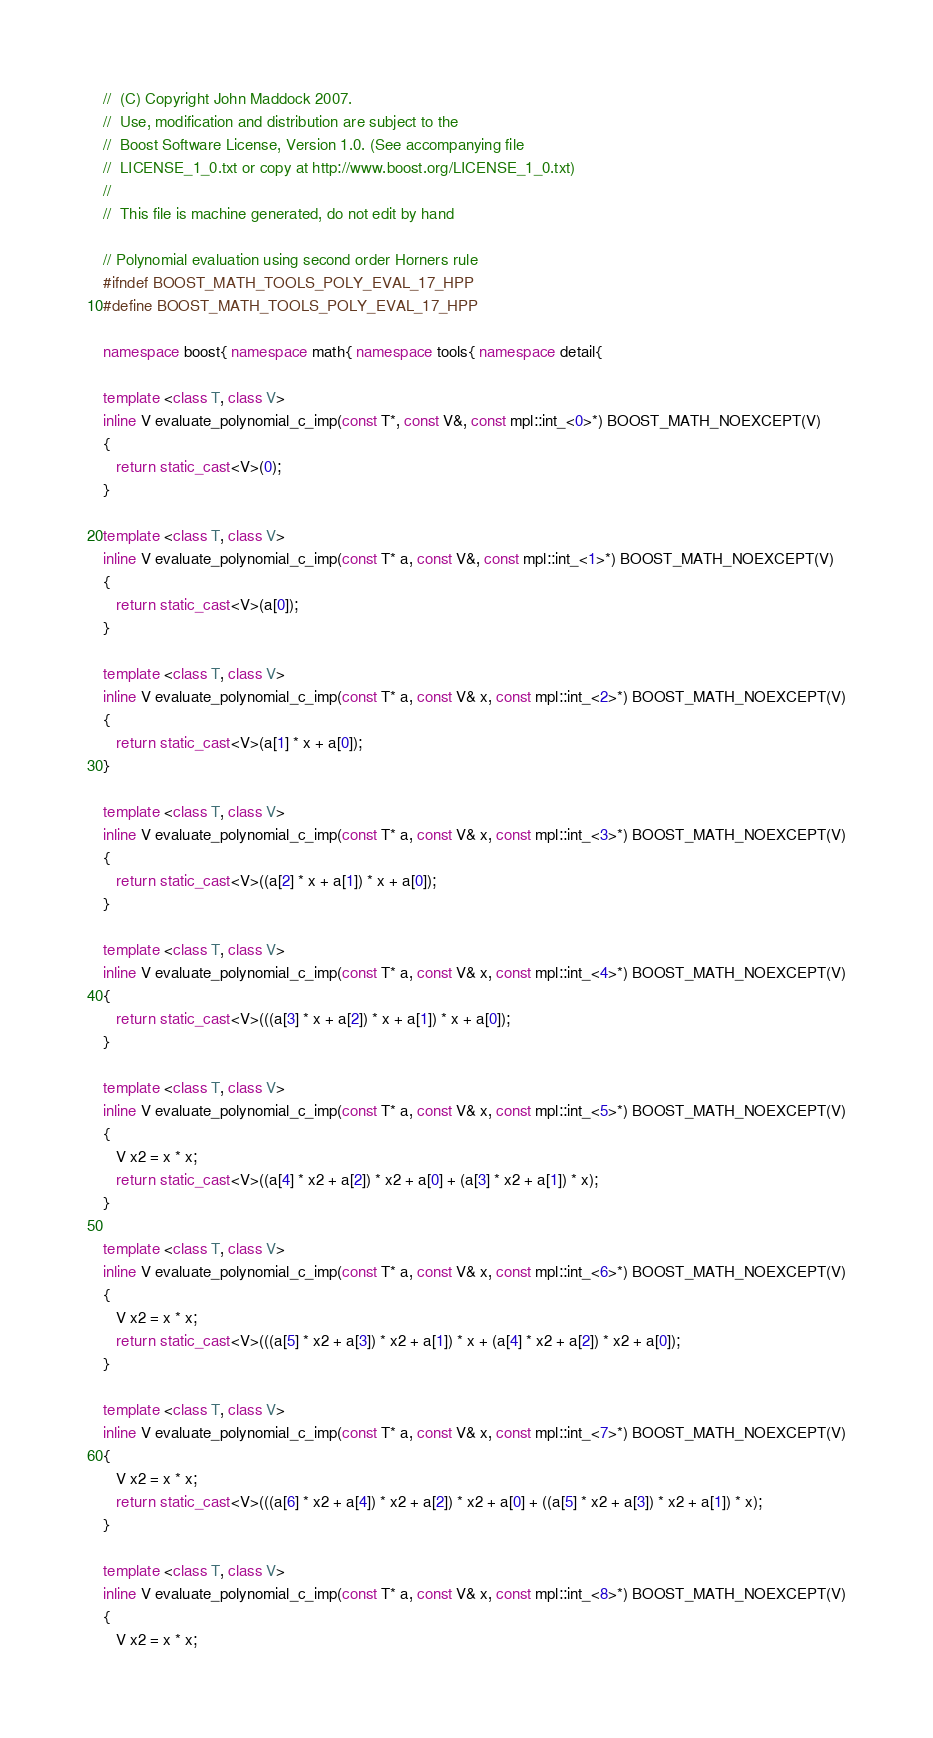<code> <loc_0><loc_0><loc_500><loc_500><_C++_>//  (C) Copyright John Maddock 2007.
//  Use, modification and distribution are subject to the
//  Boost Software License, Version 1.0. (See accompanying file
//  LICENSE_1_0.txt or copy at http://www.boost.org/LICENSE_1_0.txt)
//
//  This file is machine generated, do not edit by hand

// Polynomial evaluation using second order Horners rule
#ifndef BOOST_MATH_TOOLS_POLY_EVAL_17_HPP
#define BOOST_MATH_TOOLS_POLY_EVAL_17_HPP

namespace boost{ namespace math{ namespace tools{ namespace detail{

template <class T, class V>
inline V evaluate_polynomial_c_imp(const T*, const V&, const mpl::int_<0>*) BOOST_MATH_NOEXCEPT(V)
{
   return static_cast<V>(0);
}

template <class T, class V>
inline V evaluate_polynomial_c_imp(const T* a, const V&, const mpl::int_<1>*) BOOST_MATH_NOEXCEPT(V)
{
   return static_cast<V>(a[0]);
}

template <class T, class V>
inline V evaluate_polynomial_c_imp(const T* a, const V& x, const mpl::int_<2>*) BOOST_MATH_NOEXCEPT(V)
{
   return static_cast<V>(a[1] * x + a[0]);
}

template <class T, class V>
inline V evaluate_polynomial_c_imp(const T* a, const V& x, const mpl::int_<3>*) BOOST_MATH_NOEXCEPT(V)
{
   return static_cast<V>((a[2] * x + a[1]) * x + a[0]);
}

template <class T, class V>
inline V evaluate_polynomial_c_imp(const T* a, const V& x, const mpl::int_<4>*) BOOST_MATH_NOEXCEPT(V)
{
   return static_cast<V>(((a[3] * x + a[2]) * x + a[1]) * x + a[0]);
}

template <class T, class V>
inline V evaluate_polynomial_c_imp(const T* a, const V& x, const mpl::int_<5>*) BOOST_MATH_NOEXCEPT(V)
{
   V x2 = x * x;
   return static_cast<V>((a[4] * x2 + a[2]) * x2 + a[0] + (a[3] * x2 + a[1]) * x);
}

template <class T, class V>
inline V evaluate_polynomial_c_imp(const T* a, const V& x, const mpl::int_<6>*) BOOST_MATH_NOEXCEPT(V)
{
   V x2 = x * x;
   return static_cast<V>(((a[5] * x2 + a[3]) * x2 + a[1]) * x + (a[4] * x2 + a[2]) * x2 + a[0]);
}

template <class T, class V>
inline V evaluate_polynomial_c_imp(const T* a, const V& x, const mpl::int_<7>*) BOOST_MATH_NOEXCEPT(V)
{
   V x2 = x * x;
   return static_cast<V>(((a[6] * x2 + a[4]) * x2 + a[2]) * x2 + a[0] + ((a[5] * x2 + a[3]) * x2 + a[1]) * x);
}

template <class T, class V>
inline V evaluate_polynomial_c_imp(const T* a, const V& x, const mpl::int_<8>*) BOOST_MATH_NOEXCEPT(V)
{
   V x2 = x * x;</code> 